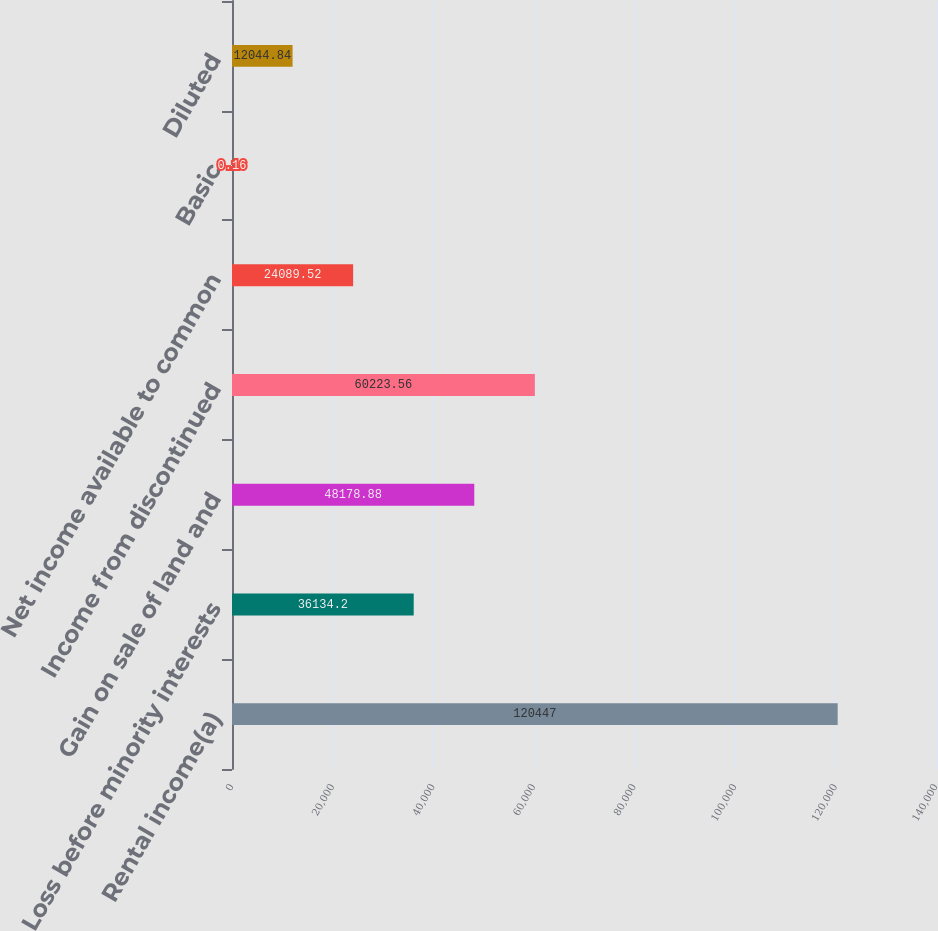<chart> <loc_0><loc_0><loc_500><loc_500><bar_chart><fcel>Rental income(a)<fcel>Loss before minority interests<fcel>Gain on sale of land and<fcel>Income from discontinued<fcel>Net income available to common<fcel>Basic<fcel>Diluted<nl><fcel>120447<fcel>36134.2<fcel>48178.9<fcel>60223.6<fcel>24089.5<fcel>0.16<fcel>12044.8<nl></chart> 